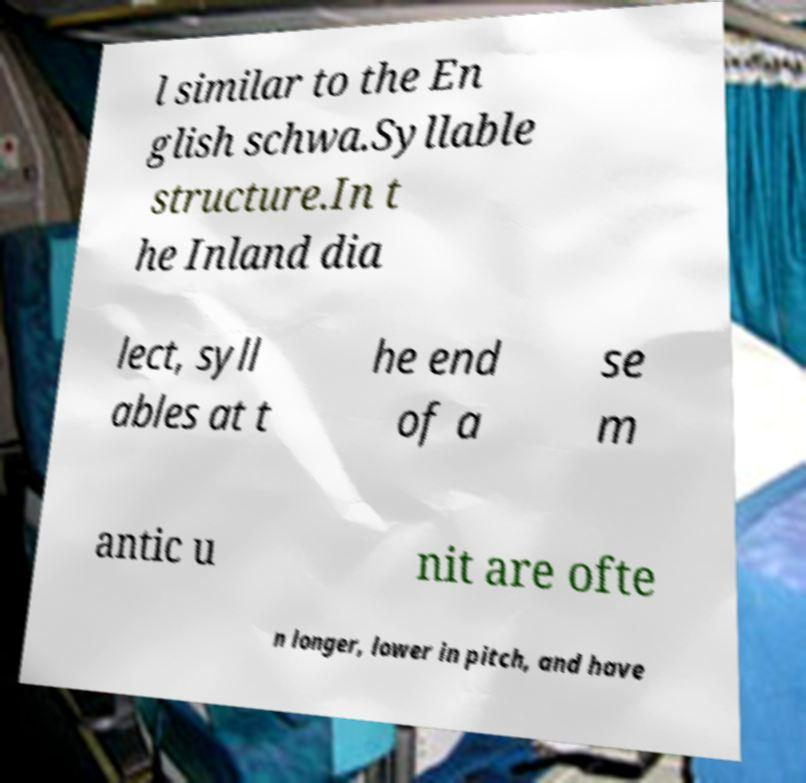There's text embedded in this image that I need extracted. Can you transcribe it verbatim? l similar to the En glish schwa.Syllable structure.In t he Inland dia lect, syll ables at t he end of a se m antic u nit are ofte n longer, lower in pitch, and have 